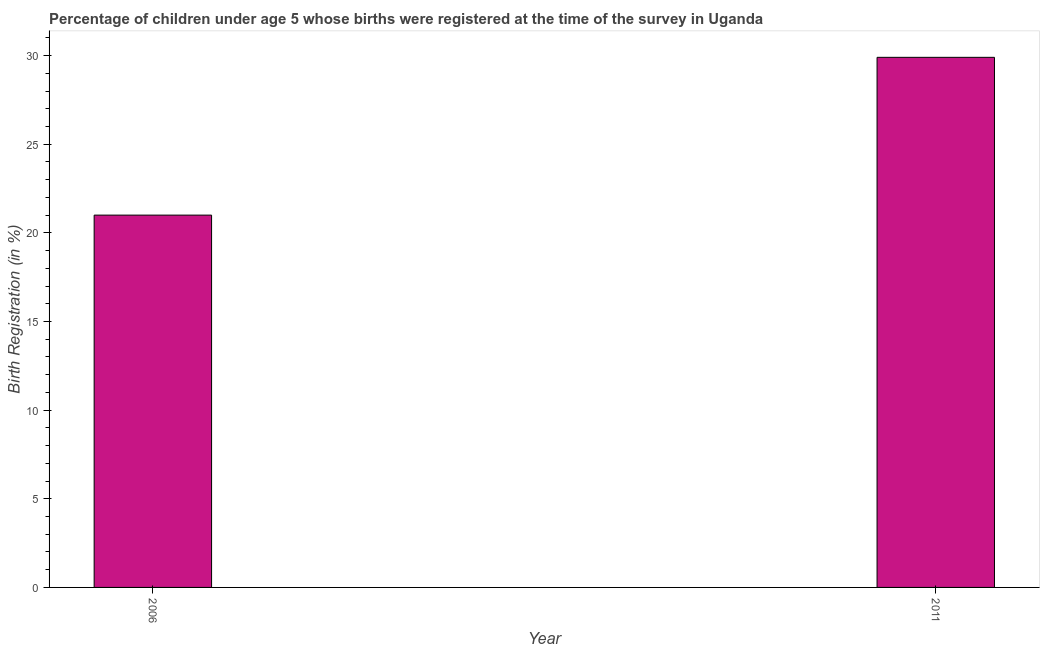Does the graph contain grids?
Ensure brevity in your answer.  No. What is the title of the graph?
Provide a short and direct response. Percentage of children under age 5 whose births were registered at the time of the survey in Uganda. What is the label or title of the Y-axis?
Offer a terse response. Birth Registration (in %). What is the birth registration in 2011?
Make the answer very short. 29.9. Across all years, what is the maximum birth registration?
Offer a very short reply. 29.9. Across all years, what is the minimum birth registration?
Ensure brevity in your answer.  21. What is the sum of the birth registration?
Keep it short and to the point. 50.9. What is the average birth registration per year?
Provide a succinct answer. 25.45. What is the median birth registration?
Give a very brief answer. 25.45. What is the ratio of the birth registration in 2006 to that in 2011?
Your response must be concise. 0.7. Are all the bars in the graph horizontal?
Your response must be concise. No. How many years are there in the graph?
Give a very brief answer. 2. What is the Birth Registration (in %) in 2006?
Your answer should be compact. 21. What is the Birth Registration (in %) of 2011?
Make the answer very short. 29.9. What is the ratio of the Birth Registration (in %) in 2006 to that in 2011?
Your answer should be very brief. 0.7. 